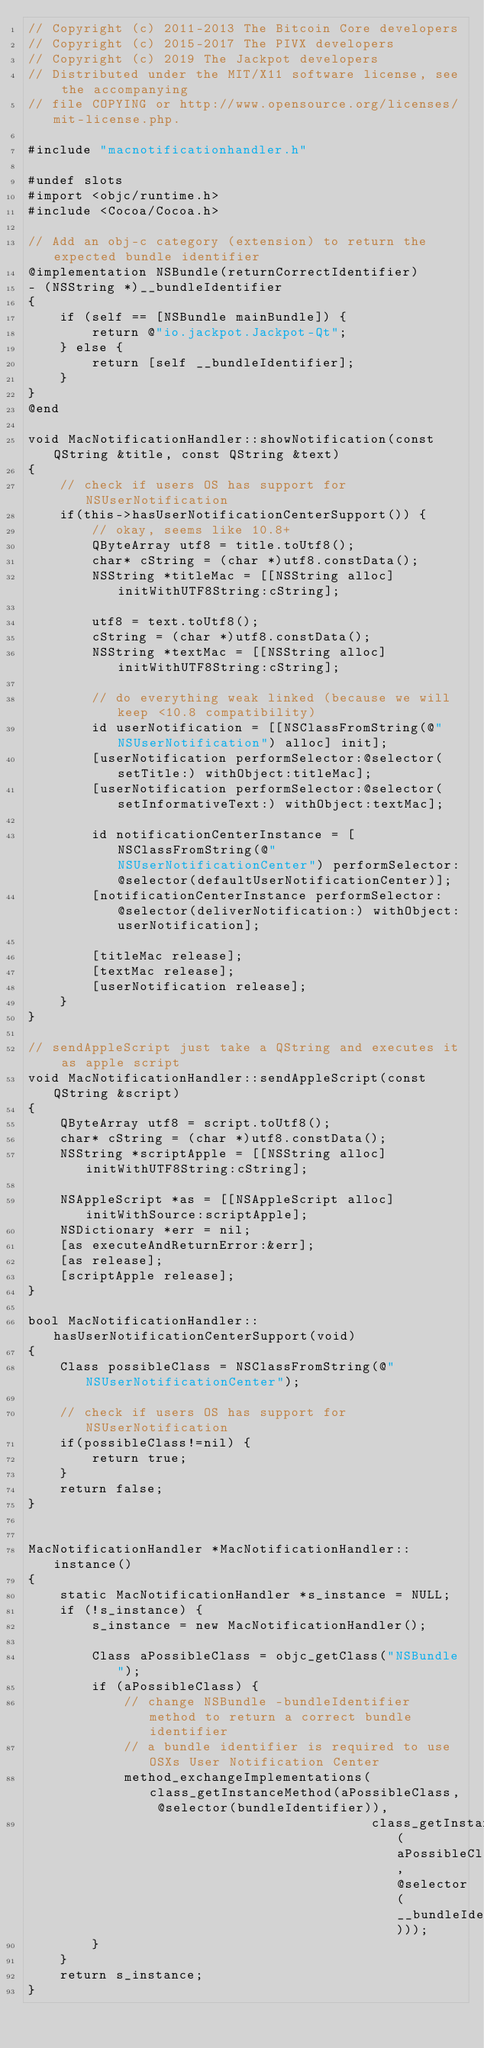Convert code to text. <code><loc_0><loc_0><loc_500><loc_500><_ObjectiveC_>// Copyright (c) 2011-2013 The Bitcoin Core developers
// Copyright (c) 2015-2017 The PIVX developers
// Copyright (c) 2019 The Jackpot developers
// Distributed under the MIT/X11 software license, see the accompanying
// file COPYING or http://www.opensource.org/licenses/mit-license.php.

#include "macnotificationhandler.h"

#undef slots
#import <objc/runtime.h>
#include <Cocoa/Cocoa.h>

// Add an obj-c category (extension) to return the expected bundle identifier
@implementation NSBundle(returnCorrectIdentifier)
- (NSString *)__bundleIdentifier
{
    if (self == [NSBundle mainBundle]) {
        return @"io.jackpot.Jackpot-Qt";
    } else {
        return [self __bundleIdentifier];
    }
}
@end

void MacNotificationHandler::showNotification(const QString &title, const QString &text)
{
    // check if users OS has support for NSUserNotification
    if(this->hasUserNotificationCenterSupport()) {
        // okay, seems like 10.8+
        QByteArray utf8 = title.toUtf8();
        char* cString = (char *)utf8.constData();
        NSString *titleMac = [[NSString alloc] initWithUTF8String:cString];

        utf8 = text.toUtf8();
        cString = (char *)utf8.constData();
        NSString *textMac = [[NSString alloc] initWithUTF8String:cString];

        // do everything weak linked (because we will keep <10.8 compatibility)
        id userNotification = [[NSClassFromString(@"NSUserNotification") alloc] init];
        [userNotification performSelector:@selector(setTitle:) withObject:titleMac];
        [userNotification performSelector:@selector(setInformativeText:) withObject:textMac];

        id notificationCenterInstance = [NSClassFromString(@"NSUserNotificationCenter") performSelector:@selector(defaultUserNotificationCenter)];
        [notificationCenterInstance performSelector:@selector(deliverNotification:) withObject:userNotification];

        [titleMac release];
        [textMac release];
        [userNotification release];
    }
}

// sendAppleScript just take a QString and executes it as apple script
void MacNotificationHandler::sendAppleScript(const QString &script)
{
    QByteArray utf8 = script.toUtf8();
    char* cString = (char *)utf8.constData();
    NSString *scriptApple = [[NSString alloc] initWithUTF8String:cString];

    NSAppleScript *as = [[NSAppleScript alloc] initWithSource:scriptApple];
    NSDictionary *err = nil;
    [as executeAndReturnError:&err];
    [as release];
    [scriptApple release];
}

bool MacNotificationHandler::hasUserNotificationCenterSupport(void)
{
    Class possibleClass = NSClassFromString(@"NSUserNotificationCenter");

    // check if users OS has support for NSUserNotification
    if(possibleClass!=nil) {
        return true;
    }
    return false;
}


MacNotificationHandler *MacNotificationHandler::instance()
{
    static MacNotificationHandler *s_instance = NULL;
    if (!s_instance) {
        s_instance = new MacNotificationHandler();
        
        Class aPossibleClass = objc_getClass("NSBundle");
        if (aPossibleClass) {
            // change NSBundle -bundleIdentifier method to return a correct bundle identifier
            // a bundle identifier is required to use OSXs User Notification Center
            method_exchangeImplementations(class_getInstanceMethod(aPossibleClass, @selector(bundleIdentifier)),
                                           class_getInstanceMethod(aPossibleClass, @selector(__bundleIdentifier)));
        }
    }
    return s_instance;
}
</code> 